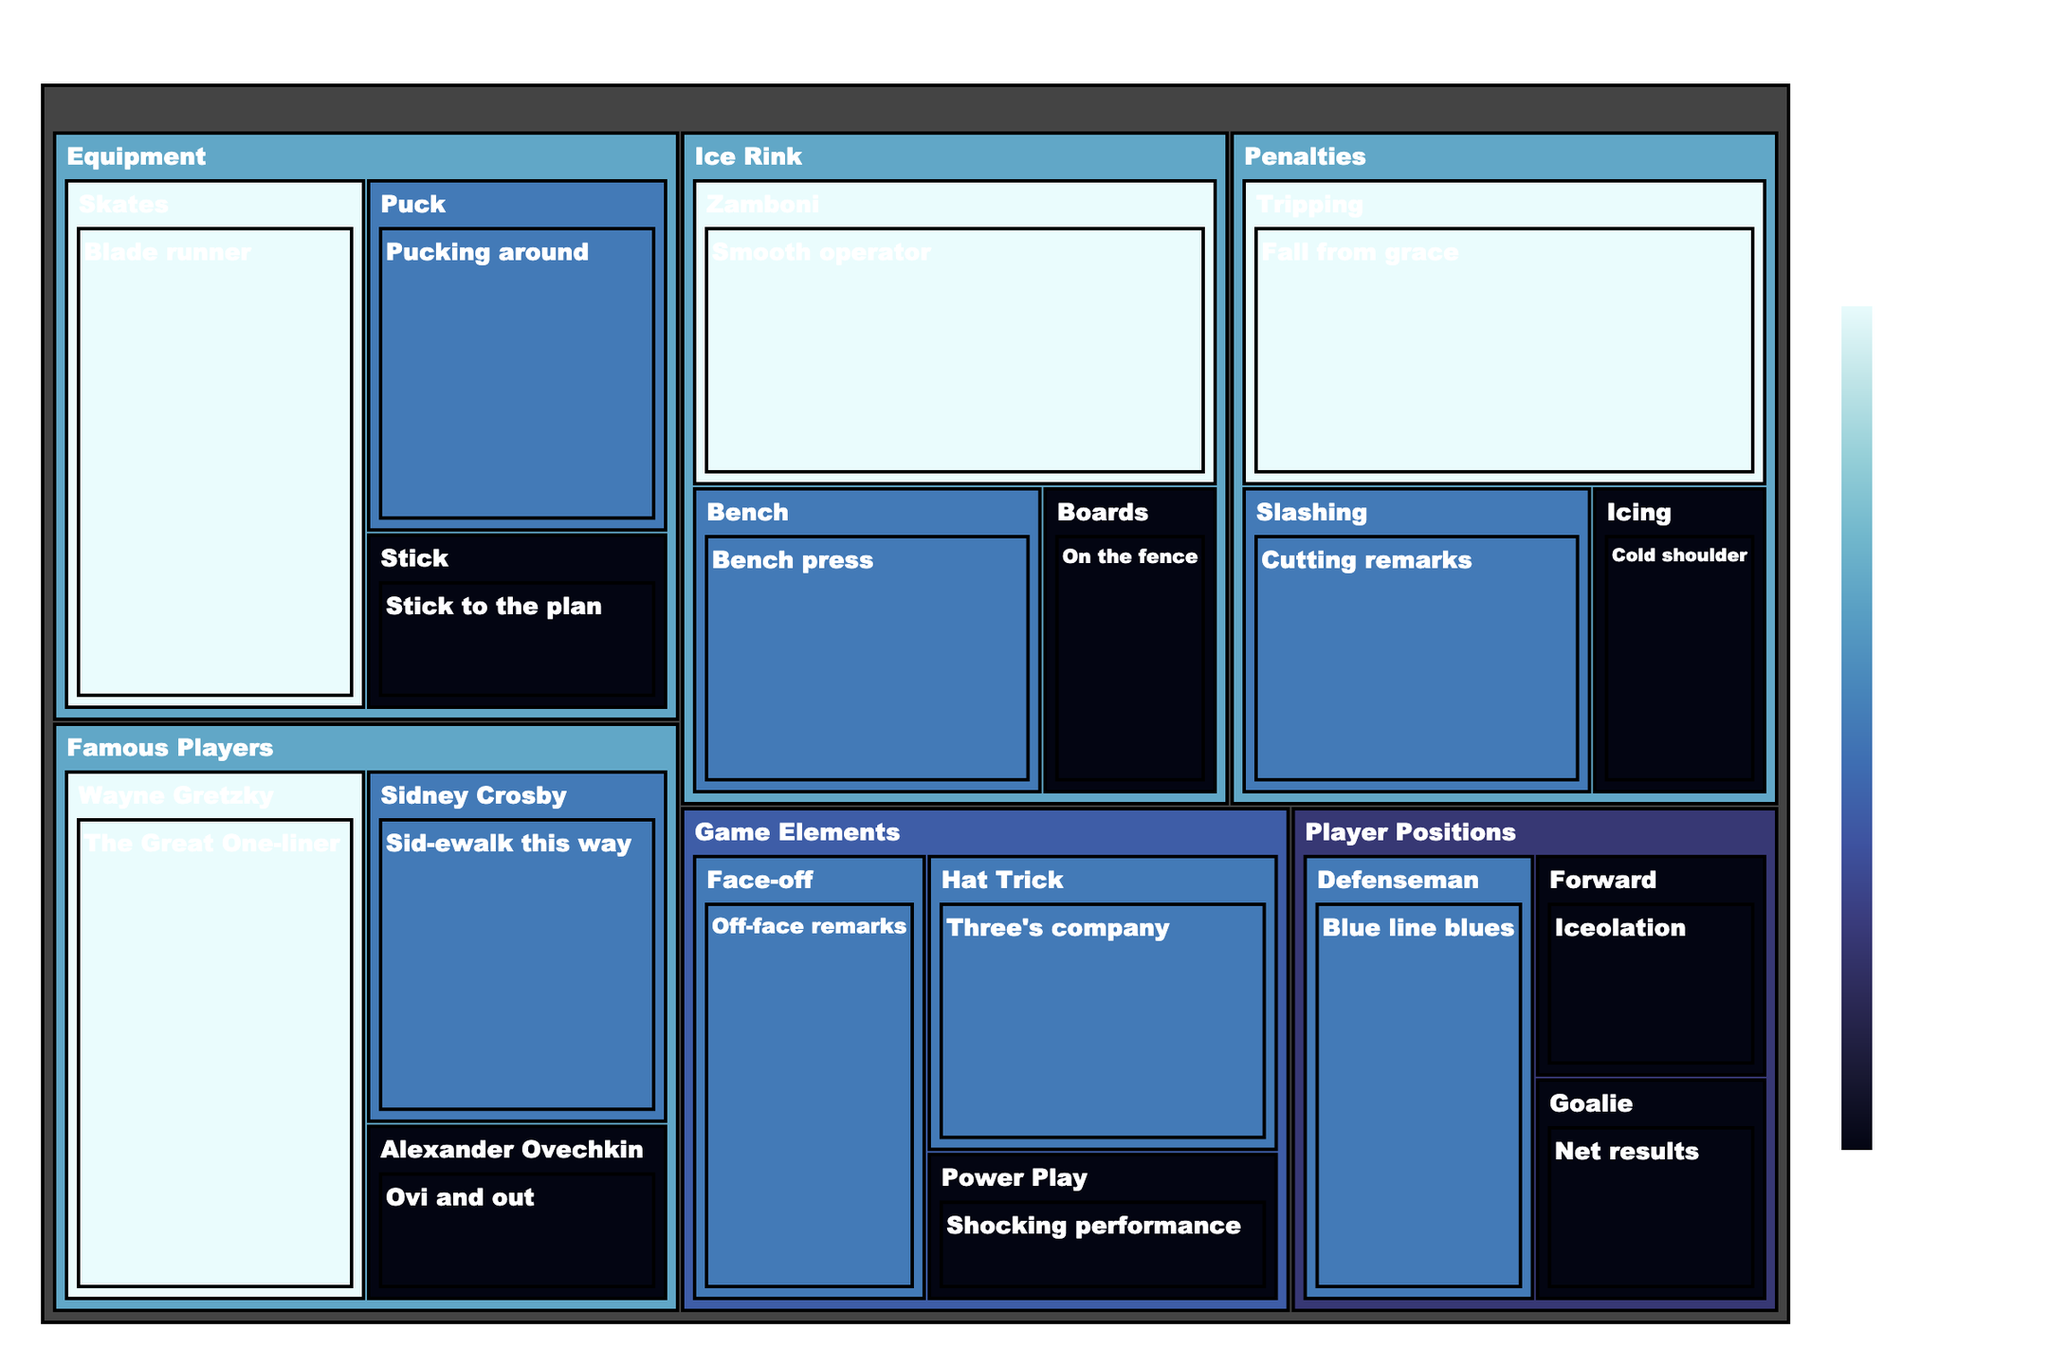what is the title of the treemap? The title usually sits at the top of a figure, making it easy to find. In this case, the title 'Hockey Puns Treemap: A Slap Shot of Humor' is displayed prominently, summarizing the main theme of the treemap.
Answer: Hockey Puns Treemap: A Slap Shot of Humor Which category has the subcategory 'Smooth operator'? Look at the structure of the treemap. Each subcategory is nested under a main category. Find 'Smooth operator' and check its parent category.
Answer: Ice Rink How many puns have a complexity of 3? To find this, look for puns labelled with a complexity of 3. There's a color coding to help; darker shades typically indicate higher complexity. Count these puns.
Answer: 4 Which subcategory in the 'Equipment' category has the highest complexity pun? Within the 'Equipment' category, identify the complexity of each pun. 'Blade runner' under 'Skates' has the highest complexity of 3.
Answer: Skates What is the most complex pun in the 'Penalties' category? Focus on the 'Penalties' category and look at the complexity scores for each pun. 'Fall from grace' related to 'Tripping' has a complexity of 3, the highest in this category.
Answer: Fall from grace Compare the complexity of puns in the 'Famous Players' category. Which player has the most complex pun? In 'Famous Players', note the complexity for Wayne Gretzky, Sidney Crosby, and Alexander Ovechkin. 'The Great One-liner' for Wayne Gretzky has the highest complexity of 3.
Answer: Wayne Gretzky Which category has the least variety of subcategories? Observe each main category and count its subcategories. The category with the least number of subcategories would be the one with the smallest count.
Answer: Game Elements How does the treemap visually distinguish between different complexities? The treemap uses a continuous color gradient to represent complexity. Lighter shades represent lower complexity, while darker shades represent higher complexity.
Answer: By color gradient Name the subcategories under 'Player Positions'. Look at the sections under 'Player Positions' in the treemap. The subcategories are 'Forward', 'Defenseman', and 'Goalie'.
Answer: Forward, Defenseman, Goalie Which subcategory in 'Game Elements' has the simplest pun? Examine the subcategories within 'Game Elements' and their associated complexities. 'Power Play's' pun 'Shocking performance' has the lowest complexity of 1.
Answer: Power Play 